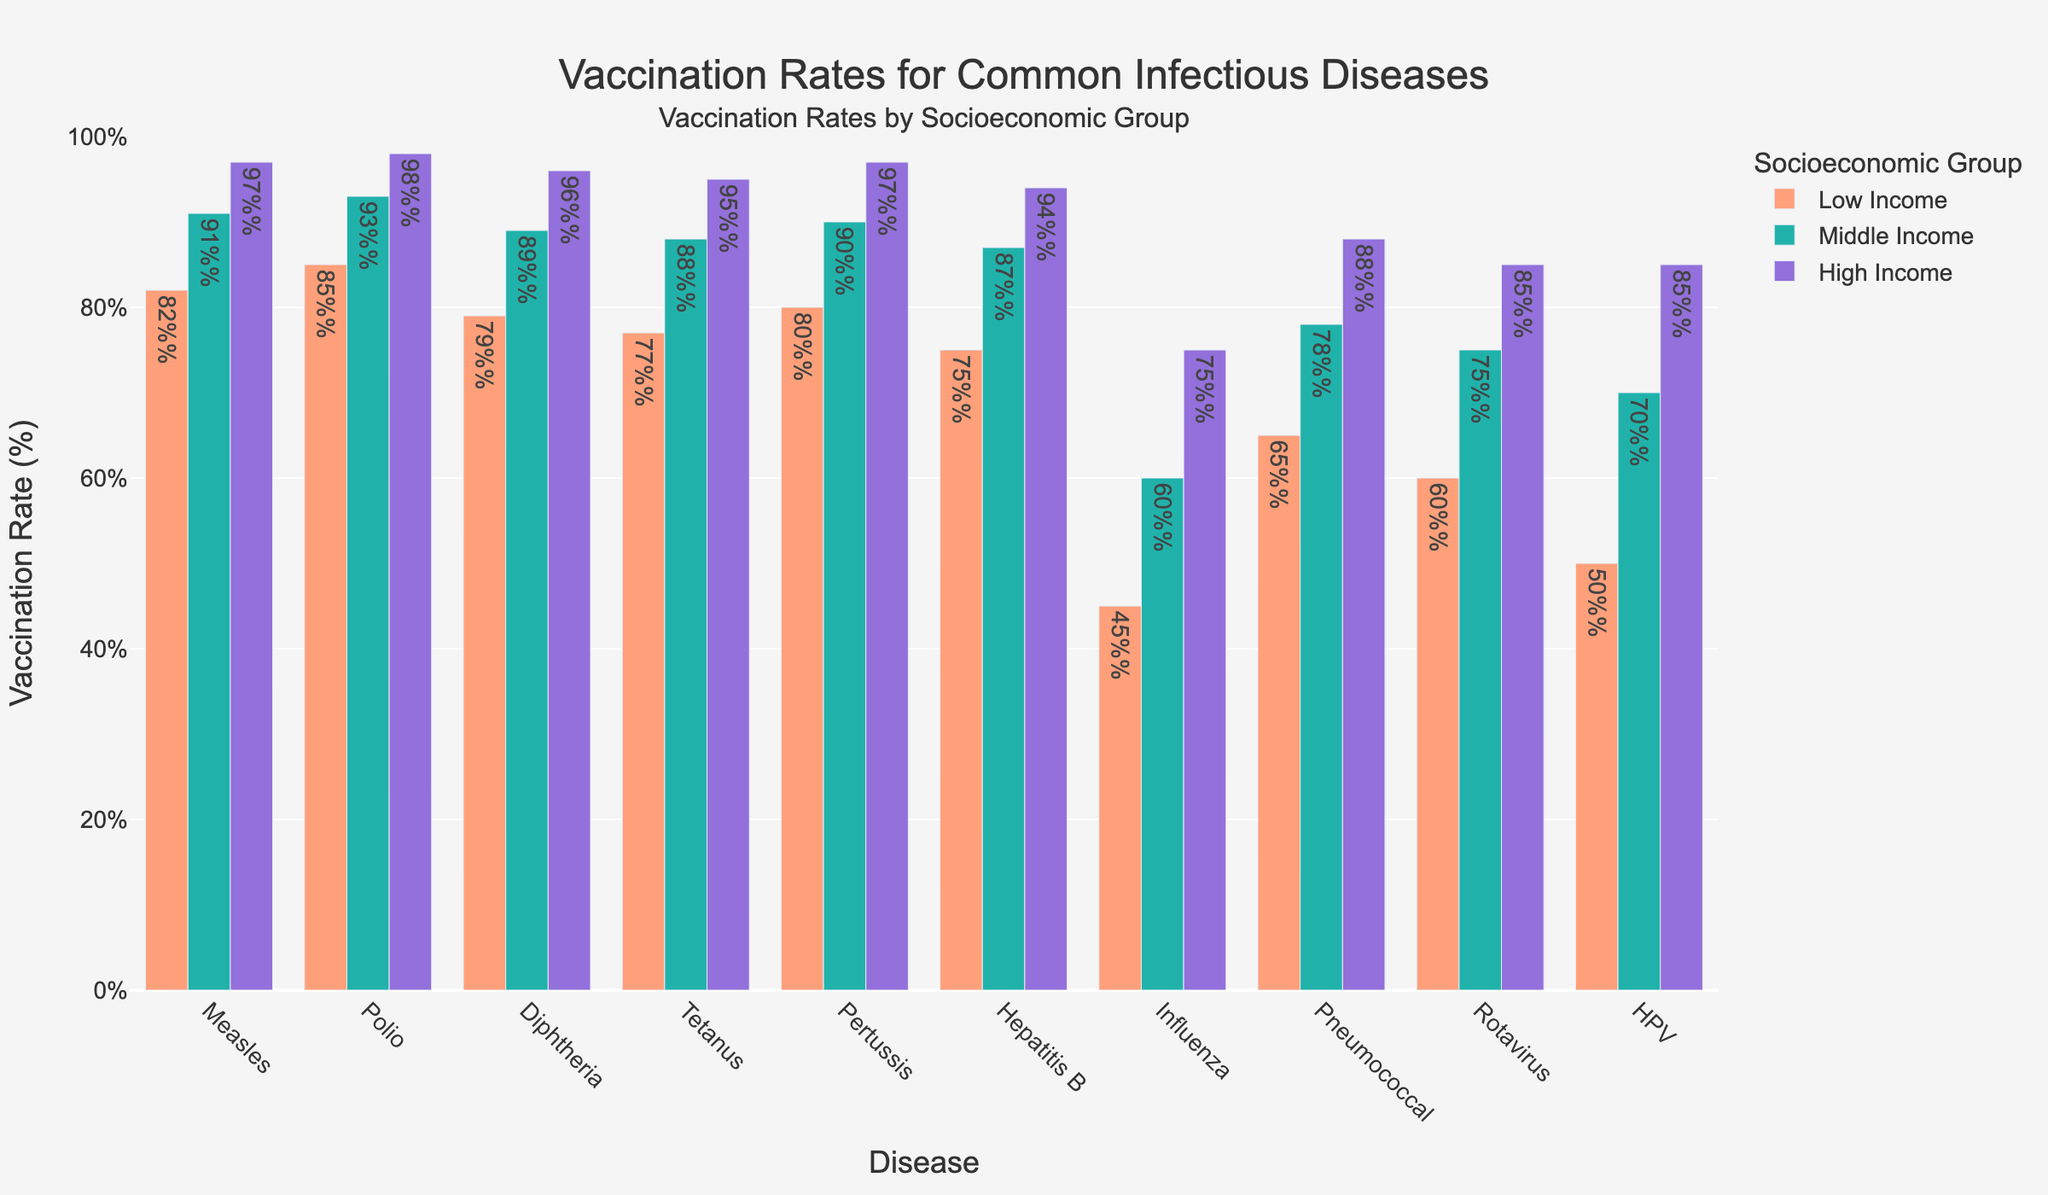Which socioeconomic group has the highest vaccination rate for Measles? The height of the bars represents the vaccination rates, and we observe that the purple bar (High Income) is the highest for Measles.
Answer: High Income What is the difference in Influenza vaccination rates between Low Income and High Income groups? The Low Income group has a vaccination rate of 45%, and the High Income group has a vaccination rate of 75%. Subtract the two rates: 75% - 45% = 30%.
Answer: 30% Which disease has the smallest gap in vaccination rates between Low Income and High Income groups? We need to compare the differences in vaccination rates between Low Income and High Income groups for each disease. The Pneumococcal vaccination rates are 65% for Low Income and 88% for High Income, which gives a difference of 23%. This is the smallest difference among all diseases.
Answer: Pneumococcal Among the three diseases Measles, Polio, and Rotavirus, which has the highest overall vaccination rate for Middle Income group? Looking at the heights of the green bars for Middle Income group for Measles (91%), Polio (93%), and Rotavirus (75%), Polio has the highest vaccination rate.
Answer: Polio What is the average vaccination rate for Diphtheria across all socioeconomic groups? The vaccination rates for Diphtheria are 79% (Low Income), 89% (Middle Income), and 96% (High Income). The average is calculated as (79 + 89 + 96) / 3 = 88%.
Answer: 88% Is there any disease where the High Income group has below 90% vaccination rate? By visually inspecting the purple bars, all diseases in the High Income group have vaccination rates above 90%, except for Influenza which has a rate of 75%. Thus, Influenza is the only disease that meets the condition.
Answer: Influenza For which diseases does the Middle Income group's vaccination rate exceed 80% but is less than 90%? We need to look at the diseases where the Middle Income group's vaccination rates (green bars) lie between 80% and 90%. These include Diphtheria (89%), Tetanus (88%), Hepatitis B (87%), and Pertussis (90%). Upon further inspection, Pertussis does not meet the condition, leaving us with three diseases.
Answer: Diphtheria, Tetanus, Hepatitis B How much higher is the vaccination rate for Rotavirus in High Income groups compared to Low Income groups? The vaccination rate for Rotavirus is 85% for High Income and 60% for Low Income. The difference is 85% - 60% = 25%.
Answer: 25% Which disease shows the largest discrepancy in vaccination rates between Low Income and Middle Income groups? Calculate the difference for each disease. The disease with the largest discrepancy is Measles, where the rates are 82% for Low Income and 91% for Middle Income, resulting in a difference of 9%.
Answer: Measles Which socioeconomic group has the lowest vaccination rate overall, and for which disease? By examining the entire figure, the lowest vaccination rate overall appears in the Low Income group's bar for Influenza, which stands at 45%.
Answer: Low Income, Influenza 